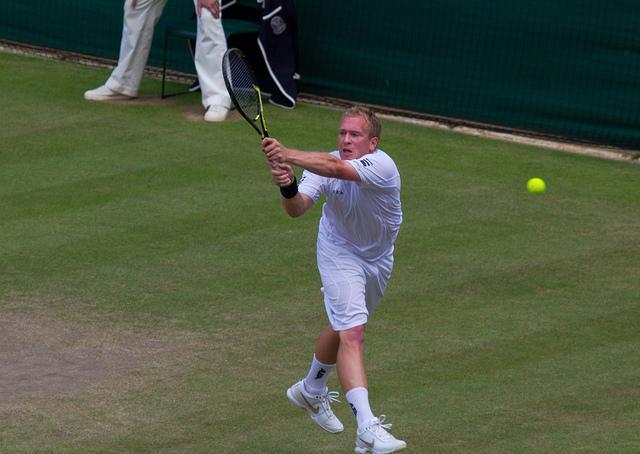How many people can you see?
Give a very brief answer. 2. 